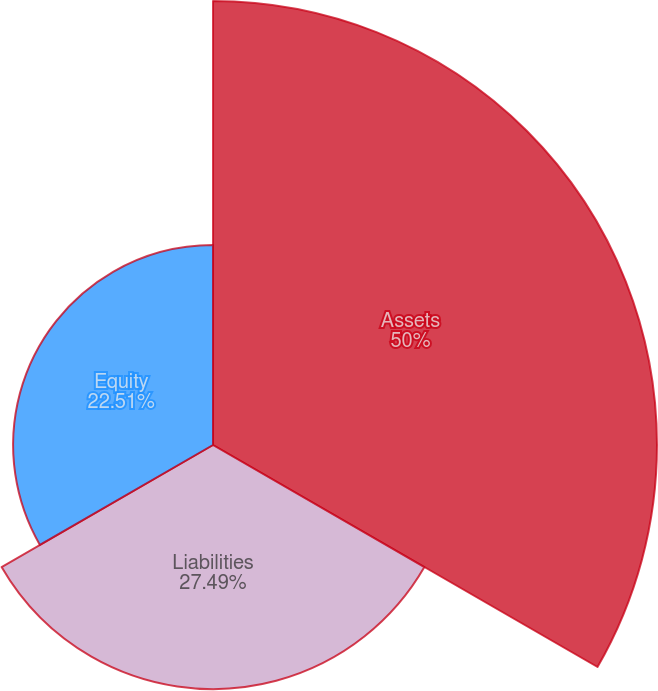Convert chart to OTSL. <chart><loc_0><loc_0><loc_500><loc_500><pie_chart><fcel>Assets<fcel>Liabilities<fcel>Equity<nl><fcel>50.0%<fcel>27.49%<fcel>22.51%<nl></chart> 